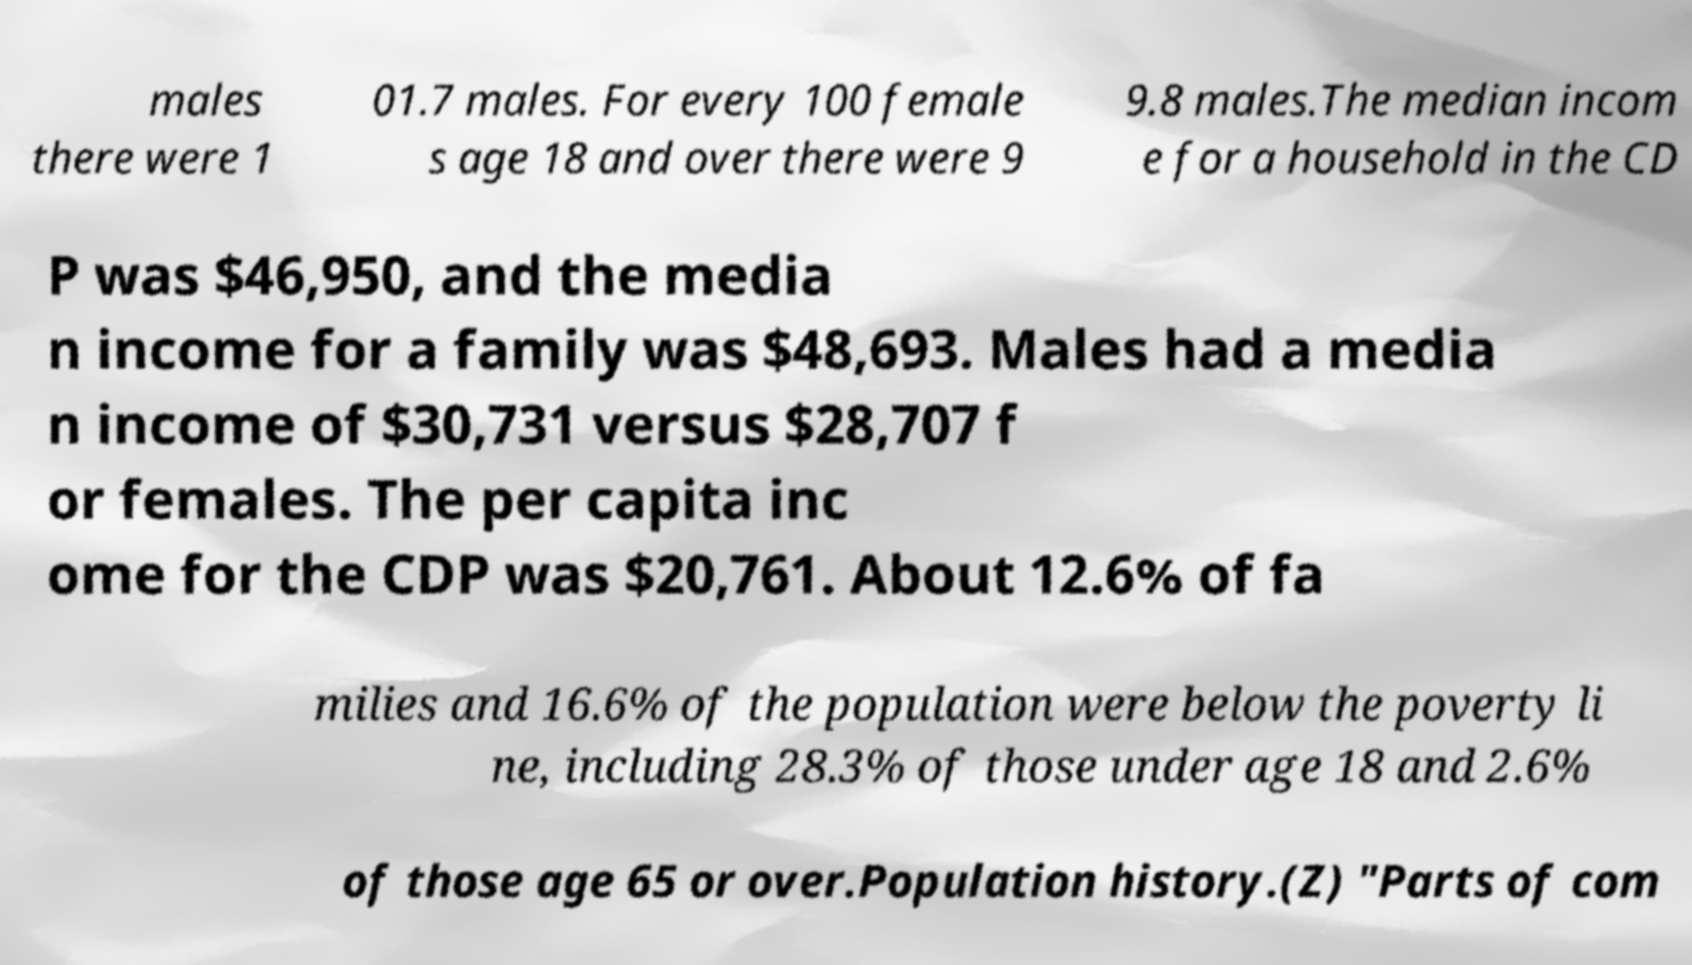I need the written content from this picture converted into text. Can you do that? males there were 1 01.7 males. For every 100 female s age 18 and over there were 9 9.8 males.The median incom e for a household in the CD P was $46,950, and the media n income for a family was $48,693. Males had a media n income of $30,731 versus $28,707 f or females. The per capita inc ome for the CDP was $20,761. About 12.6% of fa milies and 16.6% of the population were below the poverty li ne, including 28.3% of those under age 18 and 2.6% of those age 65 or over.Population history.(Z) "Parts of com 